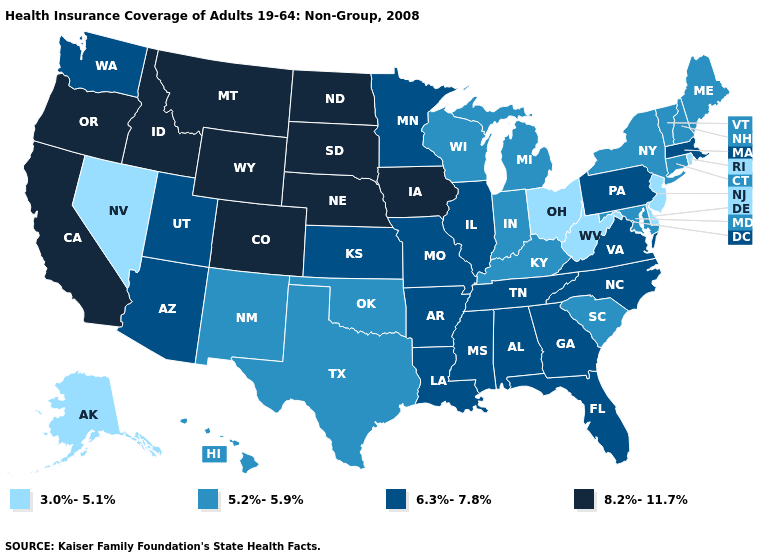What is the highest value in states that border Montana?
Short answer required. 8.2%-11.7%. What is the highest value in the Northeast ?
Keep it brief. 6.3%-7.8%. Name the states that have a value in the range 8.2%-11.7%?
Concise answer only. California, Colorado, Idaho, Iowa, Montana, Nebraska, North Dakota, Oregon, South Dakota, Wyoming. Name the states that have a value in the range 5.2%-5.9%?
Write a very short answer. Connecticut, Hawaii, Indiana, Kentucky, Maine, Maryland, Michigan, New Hampshire, New Mexico, New York, Oklahoma, South Carolina, Texas, Vermont, Wisconsin. Name the states that have a value in the range 8.2%-11.7%?
Answer briefly. California, Colorado, Idaho, Iowa, Montana, Nebraska, North Dakota, Oregon, South Dakota, Wyoming. Name the states that have a value in the range 8.2%-11.7%?
Answer briefly. California, Colorado, Idaho, Iowa, Montana, Nebraska, North Dakota, Oregon, South Dakota, Wyoming. What is the lowest value in the MidWest?
Write a very short answer. 3.0%-5.1%. Name the states that have a value in the range 6.3%-7.8%?
Concise answer only. Alabama, Arizona, Arkansas, Florida, Georgia, Illinois, Kansas, Louisiana, Massachusetts, Minnesota, Mississippi, Missouri, North Carolina, Pennsylvania, Tennessee, Utah, Virginia, Washington. What is the value of North Dakota?
Short answer required. 8.2%-11.7%. Which states have the lowest value in the West?
Give a very brief answer. Alaska, Nevada. What is the highest value in states that border North Dakota?
Quick response, please. 8.2%-11.7%. What is the highest value in the South ?
Write a very short answer. 6.3%-7.8%. Among the states that border New Jersey , which have the highest value?
Short answer required. Pennsylvania. Name the states that have a value in the range 6.3%-7.8%?
Keep it brief. Alabama, Arizona, Arkansas, Florida, Georgia, Illinois, Kansas, Louisiana, Massachusetts, Minnesota, Mississippi, Missouri, North Carolina, Pennsylvania, Tennessee, Utah, Virginia, Washington. Name the states that have a value in the range 6.3%-7.8%?
Give a very brief answer. Alabama, Arizona, Arkansas, Florida, Georgia, Illinois, Kansas, Louisiana, Massachusetts, Minnesota, Mississippi, Missouri, North Carolina, Pennsylvania, Tennessee, Utah, Virginia, Washington. 